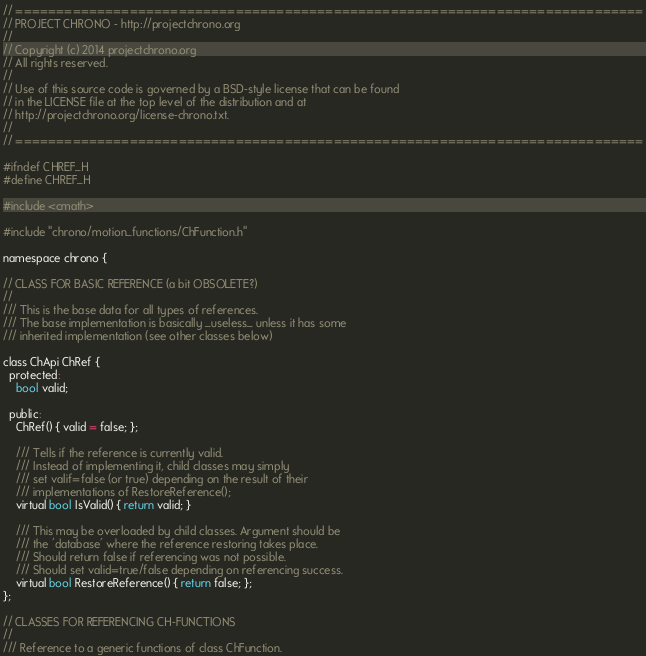Convert code to text. <code><loc_0><loc_0><loc_500><loc_500><_C_>// =============================================================================
// PROJECT CHRONO - http://projectchrono.org
//
// Copyright (c) 2014 projectchrono.org
// All rights reserved.
//
// Use of this source code is governed by a BSD-style license that can be found
// in the LICENSE file at the top level of the distribution and at
// http://projectchrono.org/license-chrono.txt.
//
// =============================================================================

#ifndef CHREF_H
#define CHREF_H

#include <cmath>

#include "chrono/motion_functions/ChFunction.h"

namespace chrono {

// CLASS FOR BASIC REFERENCE (a bit OBSOLETE?)
//
/// This is the base data for all types of references.
/// The base implementation is basically _useless_ unless it has some
/// inherited implementation (see other classes below)

class ChApi ChRef {
  protected:
    bool valid;

  public:
    ChRef() { valid = false; };

    /// Tells if the reference is currently valid.
    /// Instead of implementing it, child classes may simply
    /// set valif=false (or true) depending on the result of their
    /// implementations of RestoreReference();
    virtual bool IsValid() { return valid; }

    /// This may be overloaded by child classes. Argument should be
    /// the 'database' where the reference restoring takes place.
    /// Should return false if referencing was not possible.
    /// Should set valid=true/false depending on referencing success.
    virtual bool RestoreReference() { return false; };
};

// CLASSES FOR REFERENCING CH-FUNCTIONS
//
/// Reference to a generic functions of class ChFunction.</code> 